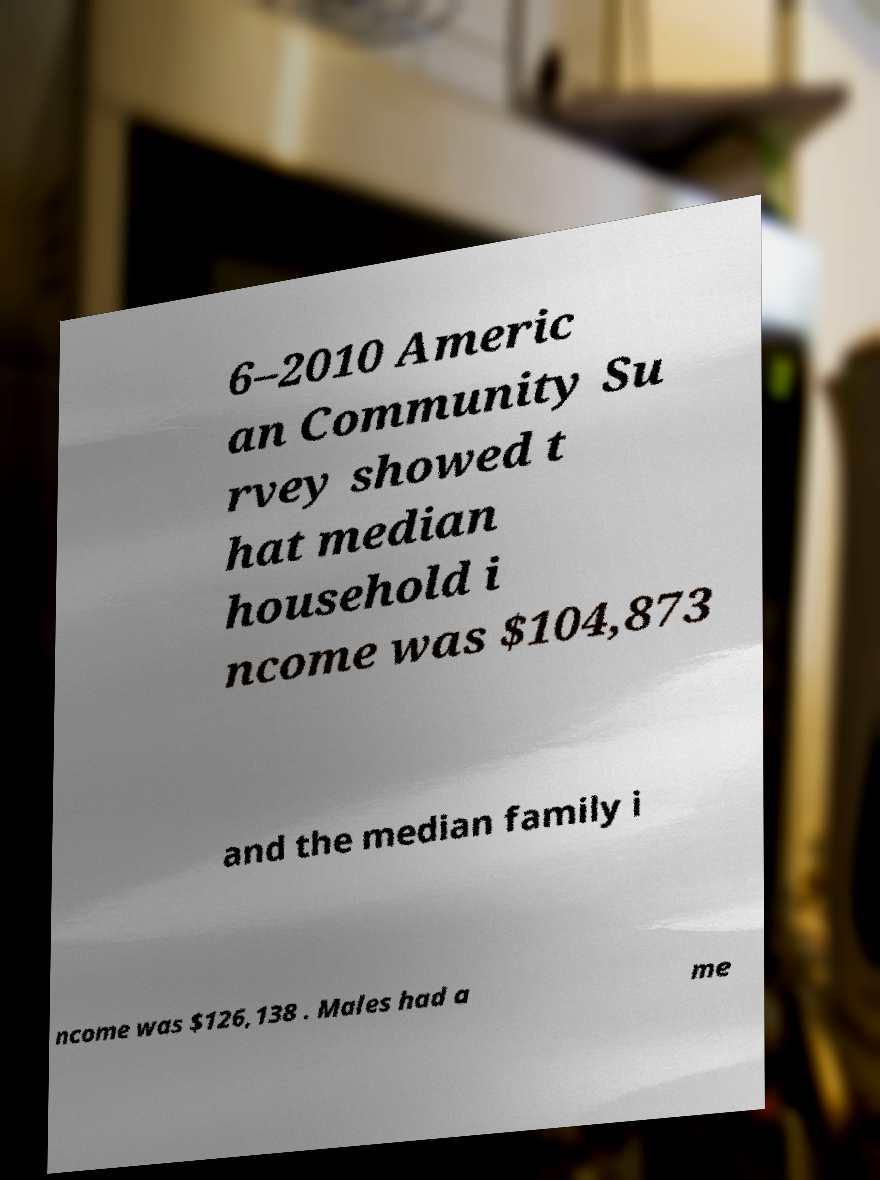Can you read and provide the text displayed in the image?This photo seems to have some interesting text. Can you extract and type it out for me? 6–2010 Americ an Community Su rvey showed t hat median household i ncome was $104,873 and the median family i ncome was $126,138 . Males had a me 